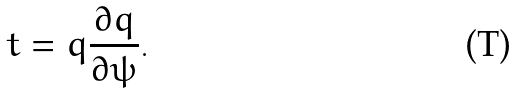Convert formula to latex. <formula><loc_0><loc_0><loc_500><loc_500>t = q \frac { \partial q } { \partial \psi } .</formula> 